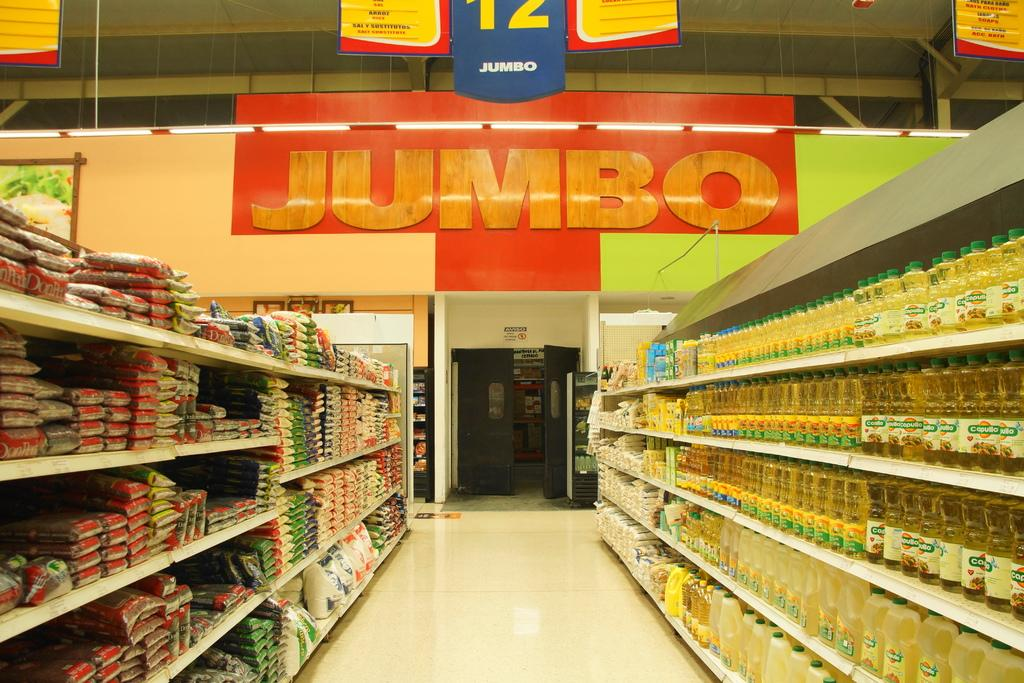<image>
Share a concise interpretation of the image provided. empty aisle which shows JUMBO in big words. 